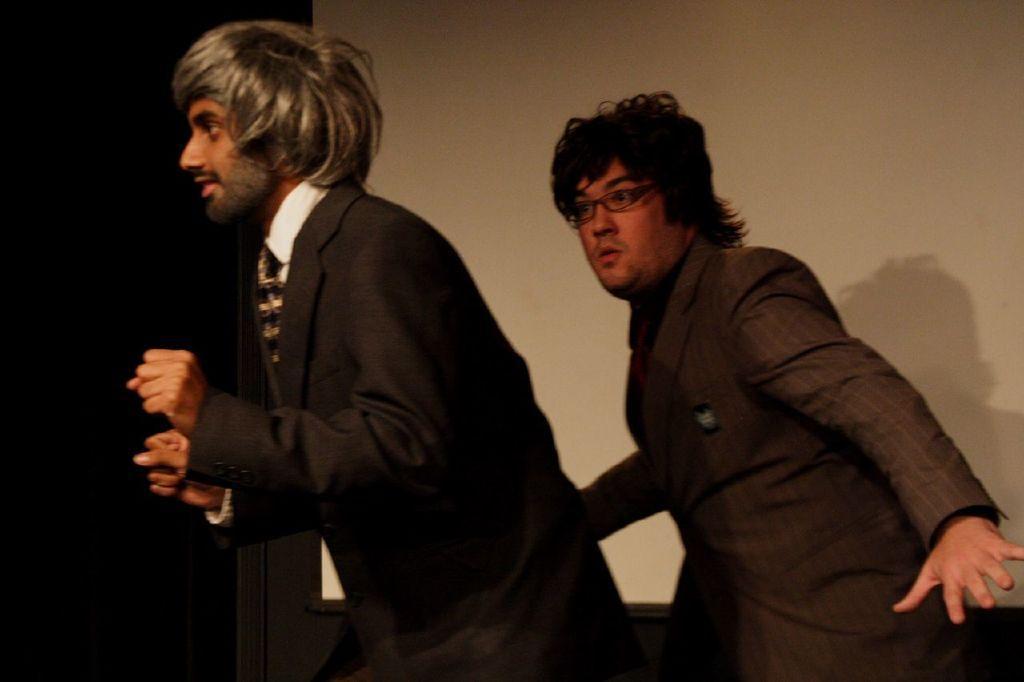Please provide a concise description of this image. On the left side, there is a person in a suit, smiling and doing a performance. On the right side, there is a person in a suit, wearing spectacle and doing a performance. In the background, there is a white color screen. And the background is dark in color. 